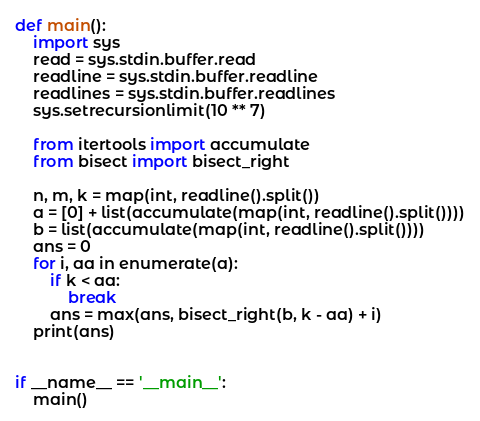<code> <loc_0><loc_0><loc_500><loc_500><_Python_>def main():
    import sys
    read = sys.stdin.buffer.read
    readline = sys.stdin.buffer.readline
    readlines = sys.stdin.buffer.readlines
    sys.setrecursionlimit(10 ** 7)

    from itertools import accumulate
    from bisect import bisect_right

    n, m, k = map(int, readline().split())
    a = [0] + list(accumulate(map(int, readline().split())))
    b = list(accumulate(map(int, readline().split())))
    ans = 0
    for i, aa in enumerate(a):
        if k < aa:
            break
        ans = max(ans, bisect_right(b, k - aa) + i)
    print(ans)


if __name__ == '__main__':
    main()
</code> 